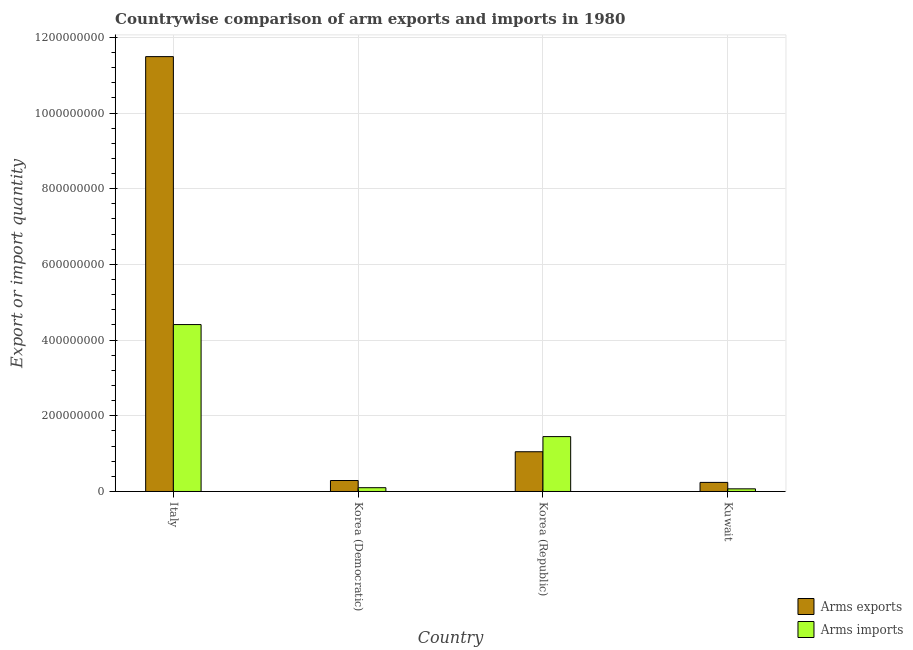How many groups of bars are there?
Your answer should be compact. 4. Are the number of bars per tick equal to the number of legend labels?
Make the answer very short. Yes. What is the label of the 2nd group of bars from the left?
Your response must be concise. Korea (Democratic). What is the arms exports in Italy?
Offer a terse response. 1.15e+09. Across all countries, what is the maximum arms imports?
Provide a short and direct response. 4.41e+08. Across all countries, what is the minimum arms exports?
Make the answer very short. 2.40e+07. In which country was the arms imports maximum?
Keep it short and to the point. Italy. In which country was the arms imports minimum?
Offer a terse response. Kuwait. What is the total arms exports in the graph?
Give a very brief answer. 1.31e+09. What is the difference between the arms exports in Italy and that in Korea (Republic)?
Provide a succinct answer. 1.04e+09. What is the difference between the arms imports in Korea (Democratic) and the arms exports in Kuwait?
Keep it short and to the point. -1.40e+07. What is the average arms imports per country?
Your response must be concise. 1.51e+08. What is the difference between the arms imports and arms exports in Italy?
Offer a terse response. -7.08e+08. In how many countries, is the arms exports greater than 1000000000 ?
Ensure brevity in your answer.  1. What is the ratio of the arms exports in Italy to that in Korea (Republic)?
Ensure brevity in your answer.  10.94. Is the arms exports in Italy less than that in Korea (Republic)?
Offer a very short reply. No. Is the difference between the arms imports in Italy and Kuwait greater than the difference between the arms exports in Italy and Kuwait?
Offer a terse response. No. What is the difference between the highest and the second highest arms exports?
Make the answer very short. 1.04e+09. What is the difference between the highest and the lowest arms exports?
Provide a short and direct response. 1.12e+09. Is the sum of the arms imports in Korea (Republic) and Kuwait greater than the maximum arms exports across all countries?
Your answer should be very brief. No. What does the 2nd bar from the left in Korea (Republic) represents?
Keep it short and to the point. Arms imports. What does the 2nd bar from the right in Korea (Republic) represents?
Ensure brevity in your answer.  Arms exports. How many bars are there?
Make the answer very short. 8. How many countries are there in the graph?
Your response must be concise. 4. What is the difference between two consecutive major ticks on the Y-axis?
Offer a very short reply. 2.00e+08. Does the graph contain grids?
Make the answer very short. Yes. How many legend labels are there?
Your answer should be compact. 2. How are the legend labels stacked?
Keep it short and to the point. Vertical. What is the title of the graph?
Your answer should be very brief. Countrywise comparison of arm exports and imports in 1980. What is the label or title of the Y-axis?
Your response must be concise. Export or import quantity. What is the Export or import quantity in Arms exports in Italy?
Give a very brief answer. 1.15e+09. What is the Export or import quantity of Arms imports in Italy?
Keep it short and to the point. 4.41e+08. What is the Export or import quantity in Arms exports in Korea (Democratic)?
Make the answer very short. 2.90e+07. What is the Export or import quantity of Arms exports in Korea (Republic)?
Ensure brevity in your answer.  1.05e+08. What is the Export or import quantity of Arms imports in Korea (Republic)?
Offer a terse response. 1.45e+08. What is the Export or import quantity of Arms exports in Kuwait?
Keep it short and to the point. 2.40e+07. What is the Export or import quantity of Arms imports in Kuwait?
Your answer should be compact. 7.00e+06. Across all countries, what is the maximum Export or import quantity of Arms exports?
Your answer should be very brief. 1.15e+09. Across all countries, what is the maximum Export or import quantity of Arms imports?
Your answer should be very brief. 4.41e+08. Across all countries, what is the minimum Export or import quantity of Arms exports?
Your answer should be compact. 2.40e+07. What is the total Export or import quantity in Arms exports in the graph?
Keep it short and to the point. 1.31e+09. What is the total Export or import quantity of Arms imports in the graph?
Your response must be concise. 6.03e+08. What is the difference between the Export or import quantity of Arms exports in Italy and that in Korea (Democratic)?
Make the answer very short. 1.12e+09. What is the difference between the Export or import quantity of Arms imports in Italy and that in Korea (Democratic)?
Offer a terse response. 4.31e+08. What is the difference between the Export or import quantity in Arms exports in Italy and that in Korea (Republic)?
Offer a terse response. 1.04e+09. What is the difference between the Export or import quantity in Arms imports in Italy and that in Korea (Republic)?
Your answer should be compact. 2.96e+08. What is the difference between the Export or import quantity of Arms exports in Italy and that in Kuwait?
Provide a succinct answer. 1.12e+09. What is the difference between the Export or import quantity of Arms imports in Italy and that in Kuwait?
Offer a terse response. 4.34e+08. What is the difference between the Export or import quantity in Arms exports in Korea (Democratic) and that in Korea (Republic)?
Your answer should be compact. -7.60e+07. What is the difference between the Export or import quantity of Arms imports in Korea (Democratic) and that in Korea (Republic)?
Offer a terse response. -1.35e+08. What is the difference between the Export or import quantity in Arms exports in Korea (Republic) and that in Kuwait?
Your answer should be very brief. 8.10e+07. What is the difference between the Export or import quantity in Arms imports in Korea (Republic) and that in Kuwait?
Offer a terse response. 1.38e+08. What is the difference between the Export or import quantity of Arms exports in Italy and the Export or import quantity of Arms imports in Korea (Democratic)?
Make the answer very short. 1.14e+09. What is the difference between the Export or import quantity of Arms exports in Italy and the Export or import quantity of Arms imports in Korea (Republic)?
Make the answer very short. 1.00e+09. What is the difference between the Export or import quantity of Arms exports in Italy and the Export or import quantity of Arms imports in Kuwait?
Keep it short and to the point. 1.14e+09. What is the difference between the Export or import quantity of Arms exports in Korea (Democratic) and the Export or import quantity of Arms imports in Korea (Republic)?
Make the answer very short. -1.16e+08. What is the difference between the Export or import quantity of Arms exports in Korea (Democratic) and the Export or import quantity of Arms imports in Kuwait?
Ensure brevity in your answer.  2.20e+07. What is the difference between the Export or import quantity of Arms exports in Korea (Republic) and the Export or import quantity of Arms imports in Kuwait?
Offer a terse response. 9.80e+07. What is the average Export or import quantity in Arms exports per country?
Provide a succinct answer. 3.27e+08. What is the average Export or import quantity in Arms imports per country?
Your answer should be compact. 1.51e+08. What is the difference between the Export or import quantity in Arms exports and Export or import quantity in Arms imports in Italy?
Provide a succinct answer. 7.08e+08. What is the difference between the Export or import quantity in Arms exports and Export or import quantity in Arms imports in Korea (Democratic)?
Ensure brevity in your answer.  1.90e+07. What is the difference between the Export or import quantity in Arms exports and Export or import quantity in Arms imports in Korea (Republic)?
Ensure brevity in your answer.  -4.00e+07. What is the difference between the Export or import quantity in Arms exports and Export or import quantity in Arms imports in Kuwait?
Offer a terse response. 1.70e+07. What is the ratio of the Export or import quantity in Arms exports in Italy to that in Korea (Democratic)?
Offer a terse response. 39.62. What is the ratio of the Export or import quantity of Arms imports in Italy to that in Korea (Democratic)?
Provide a succinct answer. 44.1. What is the ratio of the Export or import quantity of Arms exports in Italy to that in Korea (Republic)?
Your answer should be very brief. 10.94. What is the ratio of the Export or import quantity of Arms imports in Italy to that in Korea (Republic)?
Your answer should be compact. 3.04. What is the ratio of the Export or import quantity of Arms exports in Italy to that in Kuwait?
Provide a succinct answer. 47.88. What is the ratio of the Export or import quantity of Arms exports in Korea (Democratic) to that in Korea (Republic)?
Provide a succinct answer. 0.28. What is the ratio of the Export or import quantity in Arms imports in Korea (Democratic) to that in Korea (Republic)?
Provide a succinct answer. 0.07. What is the ratio of the Export or import quantity of Arms exports in Korea (Democratic) to that in Kuwait?
Make the answer very short. 1.21. What is the ratio of the Export or import quantity in Arms imports in Korea (Democratic) to that in Kuwait?
Offer a terse response. 1.43. What is the ratio of the Export or import quantity of Arms exports in Korea (Republic) to that in Kuwait?
Your answer should be compact. 4.38. What is the ratio of the Export or import quantity of Arms imports in Korea (Republic) to that in Kuwait?
Your answer should be compact. 20.71. What is the difference between the highest and the second highest Export or import quantity in Arms exports?
Keep it short and to the point. 1.04e+09. What is the difference between the highest and the second highest Export or import quantity of Arms imports?
Your answer should be compact. 2.96e+08. What is the difference between the highest and the lowest Export or import quantity of Arms exports?
Offer a very short reply. 1.12e+09. What is the difference between the highest and the lowest Export or import quantity of Arms imports?
Your answer should be compact. 4.34e+08. 